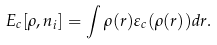<formula> <loc_0><loc_0><loc_500><loc_500>E _ { c } [ \rho , n _ { i } ] = \int \rho ( { r } ) \varepsilon _ { c } ( \rho ( { r } ) ) d { r } .</formula> 